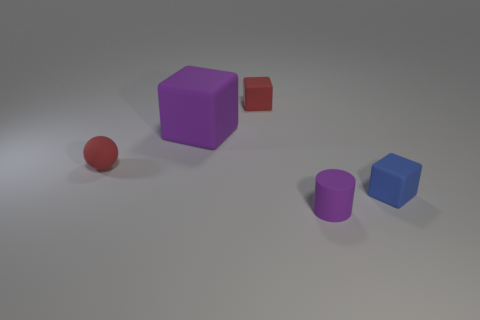What color is the rubber sphere that is the same size as the purple matte cylinder?
Provide a short and direct response. Red. There is a blue cube; is it the same size as the red matte thing that is on the right side of the tiny sphere?
Give a very brief answer. Yes. How many small things are the same color as the ball?
Ensure brevity in your answer.  1. How many objects are large purple cubes or purple things that are behind the blue cube?
Keep it short and to the point. 1. There is a red thing to the left of the large purple cube; is it the same size as the purple thing to the right of the large purple cube?
Offer a terse response. Yes. Is there a big gray sphere made of the same material as the small blue cube?
Provide a short and direct response. No. The large purple object is what shape?
Keep it short and to the point. Cube. There is a red matte object right of the purple matte thing behind the small cylinder; what shape is it?
Offer a terse response. Cube. How many other things are there of the same shape as the small purple thing?
Provide a succinct answer. 0. There is a cube in front of the small rubber object to the left of the small red cube; what is its size?
Ensure brevity in your answer.  Small. 